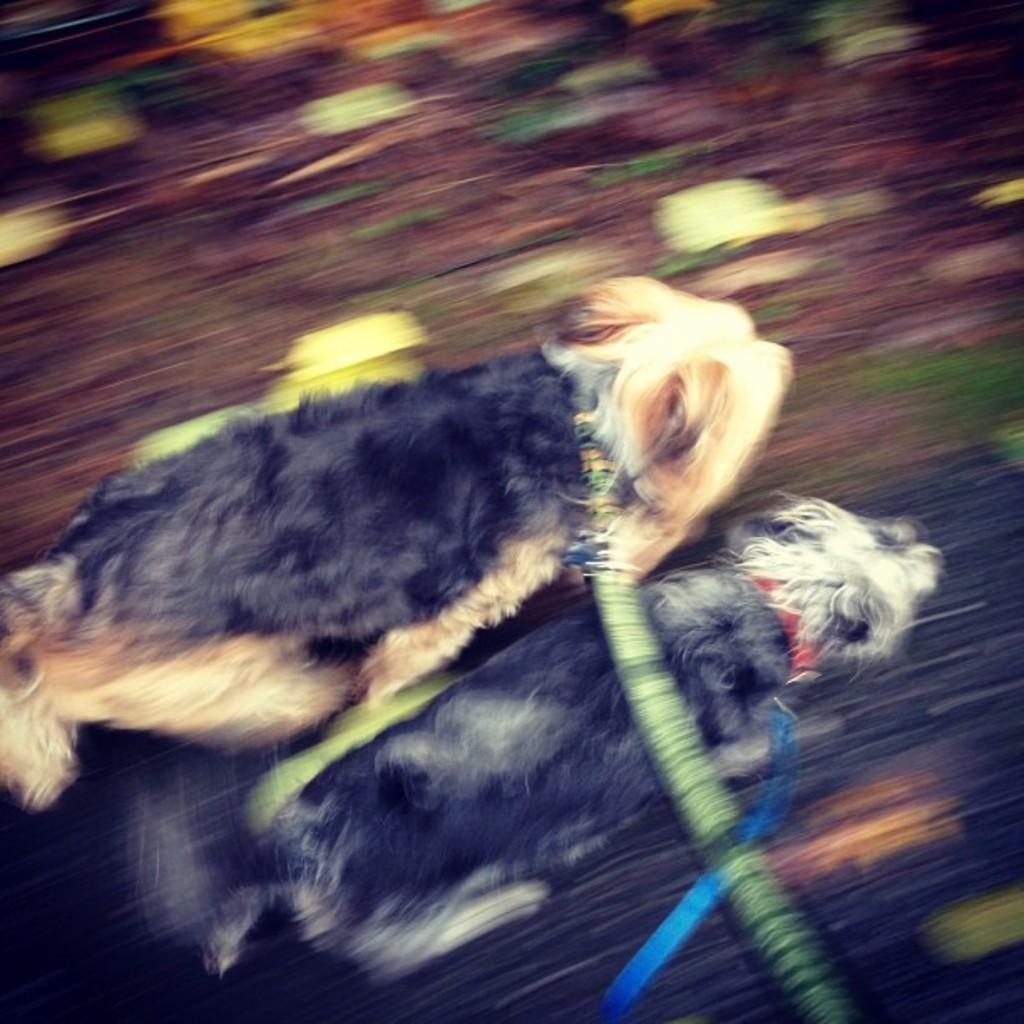What animals can be seen in the image? There are two dogs in the image, although the blurriness may affect the certainty of this observation. What objects are present in the image? There are belts in the image, although the blurriness may affect the certainty of this observation. Can you see a cow in the image? No, there is no cow present in the image. What is the need for a spoon in the image? There is no spoon present in the image, so there is no need for one. 